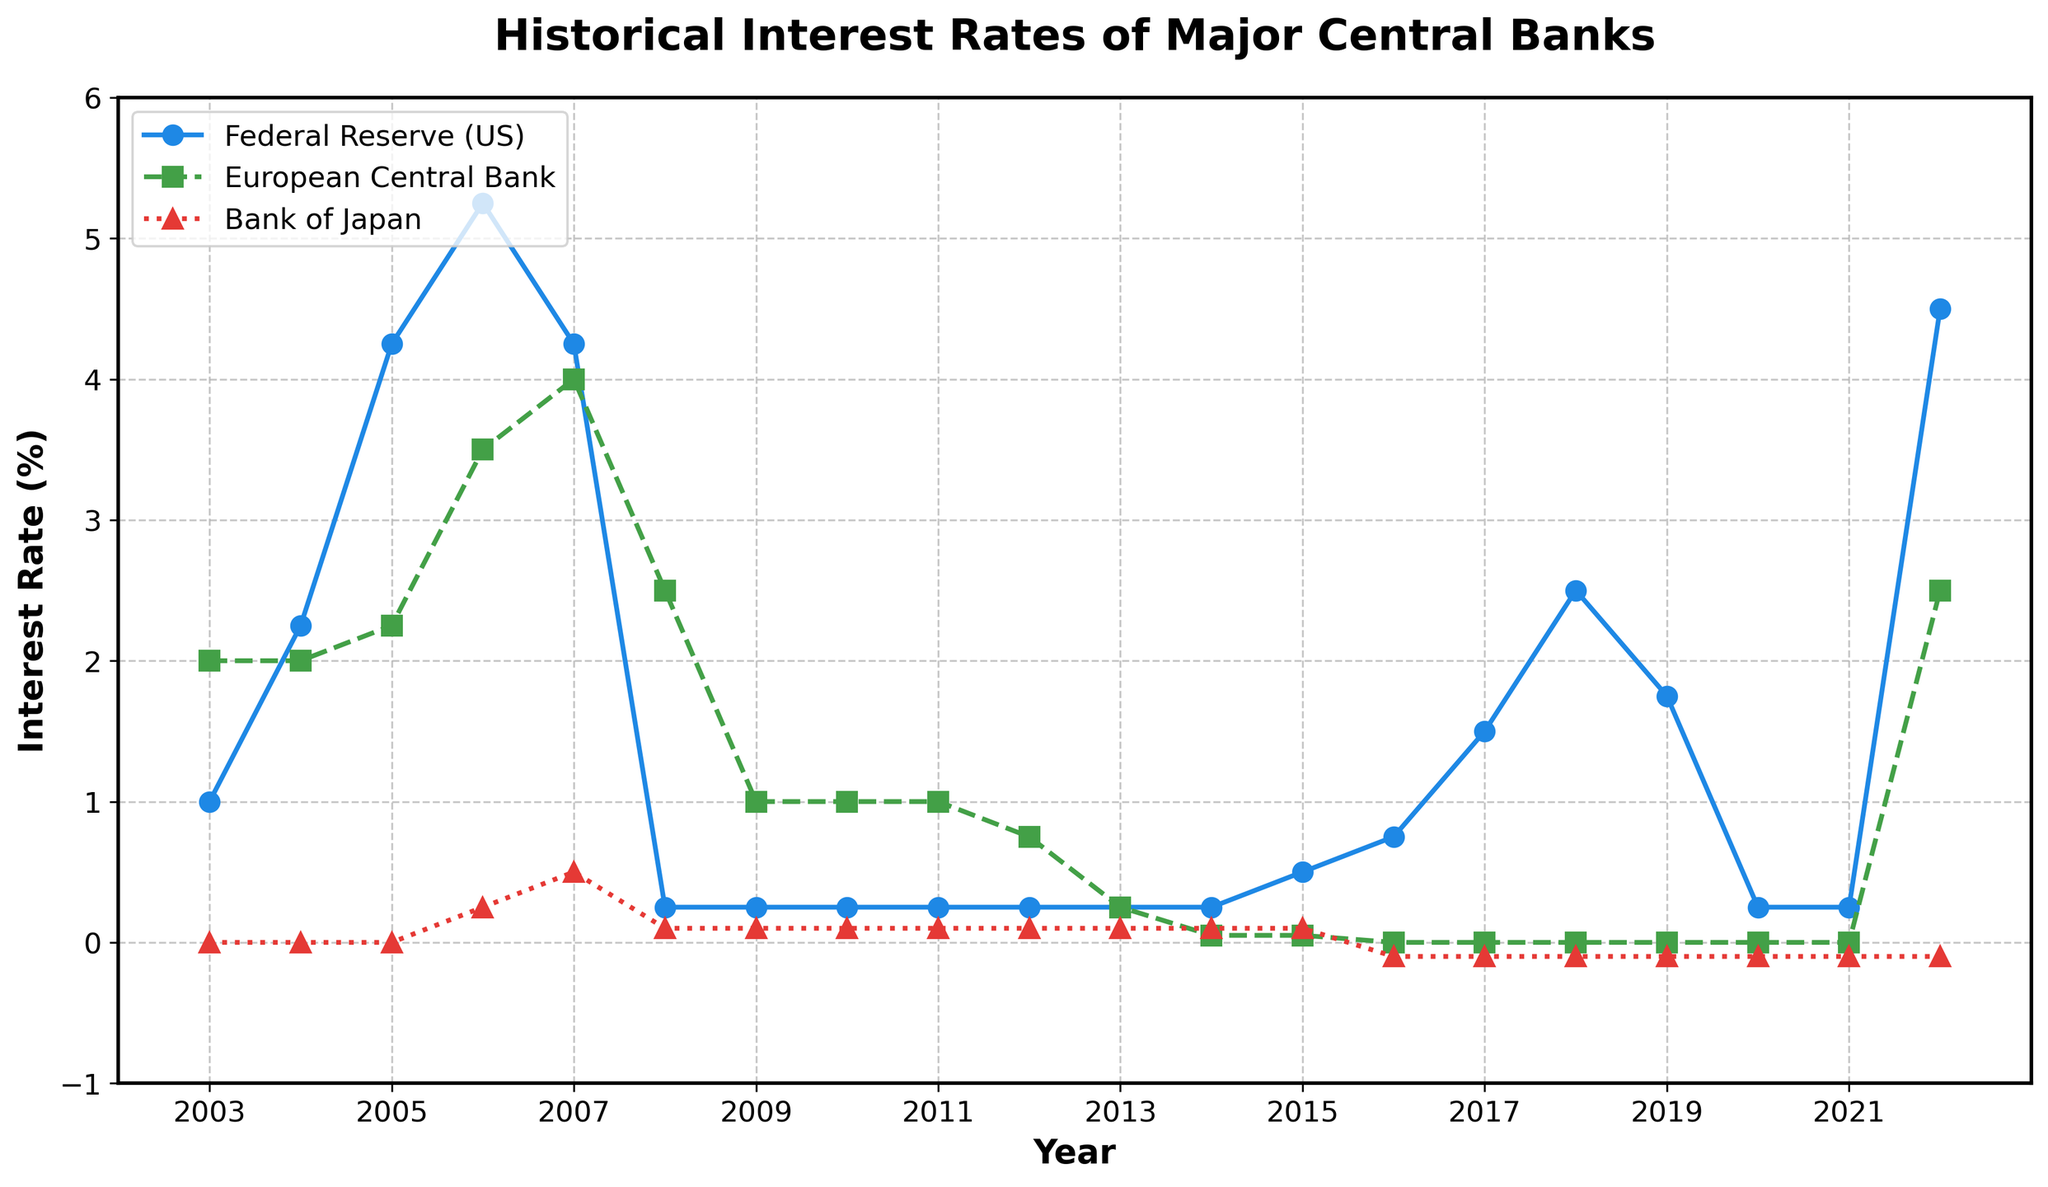What was the highest interest rate set by the Federal Reserve (US) over the 20-year period? To find the highest interest rate, look at the y-values associated with the Federal Reserve (US) line. The peak value is at 2006 where the interest rate was 5.25%.
Answer: 5.25% In which year did the European Central Bank and the Bank of Japan both have 0% interest rate? Observe the points on the lines for the European Central Bank and the Bank of Japan. Both lines intersect the 0% interest rate in the year 2016.
Answer: 2016 Which central bank had the most consistent (least variation) interest rate over the last 20 years? By visually inspecting the lines, the Bank of Japan's line shows minimal changes fluctuating around 0%, compared to the other two central banks.
Answer: Bank of Japan How many years did the Federal Reserve (US) maintain an interest rate of 0.25%? Identify the flat segments on the Federal Reserve (US) line. The segments are from 2008 to 2015 and from 2020 to 2021, totaling 9 years.
Answer: 9 years What was the combined interest rate of the Federal Reserve (US) and European Central Bank in 2018? Add the interest rates in 2018 for both, 2.50% (Federal Reserve) and 0.00% (ECB). The combined rate is 2.50%.
Answer: 2.50% Compare the interest rates of the European Central Bank and the Federal Reserve in 2007. Which one was higher? Look at both lines' y-values in 2007: the Federal Reserve was at 4.25%, and the European Central Bank was at 4.00%. The Federal Reserve had the higher rate.
Answer: Federal Reserve How many times did the Bank of Japan set a negative interest rate, and in which years? Negative interest rates for the Bank of Japan were evident when the line dipped below 0%. This happened from 2016 to 2022 (7 years).
Answer: 7 years (2016-2022) Which central bank had the highest increase in interest rate in a single year, and what was the increase? Check for the steepest slope between two consecutive years. Between 2021 and 2022, the Federal Reserve jumped from 0.25% to 4.50%, an increase of 4.25%.
Answer: Federal Reserve, 4.25% 